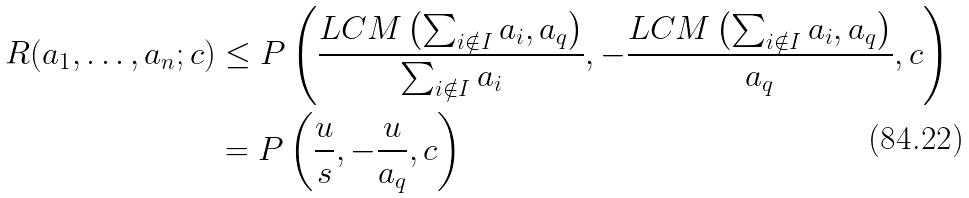<formula> <loc_0><loc_0><loc_500><loc_500>R ( a _ { 1 } , \dots , a _ { n } ; c ) & \leq P \left ( \frac { L C M \left ( \sum _ { i \notin I } a _ { i } , a _ { q } \right ) } { \sum _ { i \notin I } a _ { i } } , - \frac { L C M \left ( \sum _ { i \notin I } a _ { i } , a _ { q } \right ) } { a _ { q } } , c \right ) \\ & = P \left ( \frac { u } { s } , - \frac { u } { a _ { q } } , c \right ) \\</formula> 